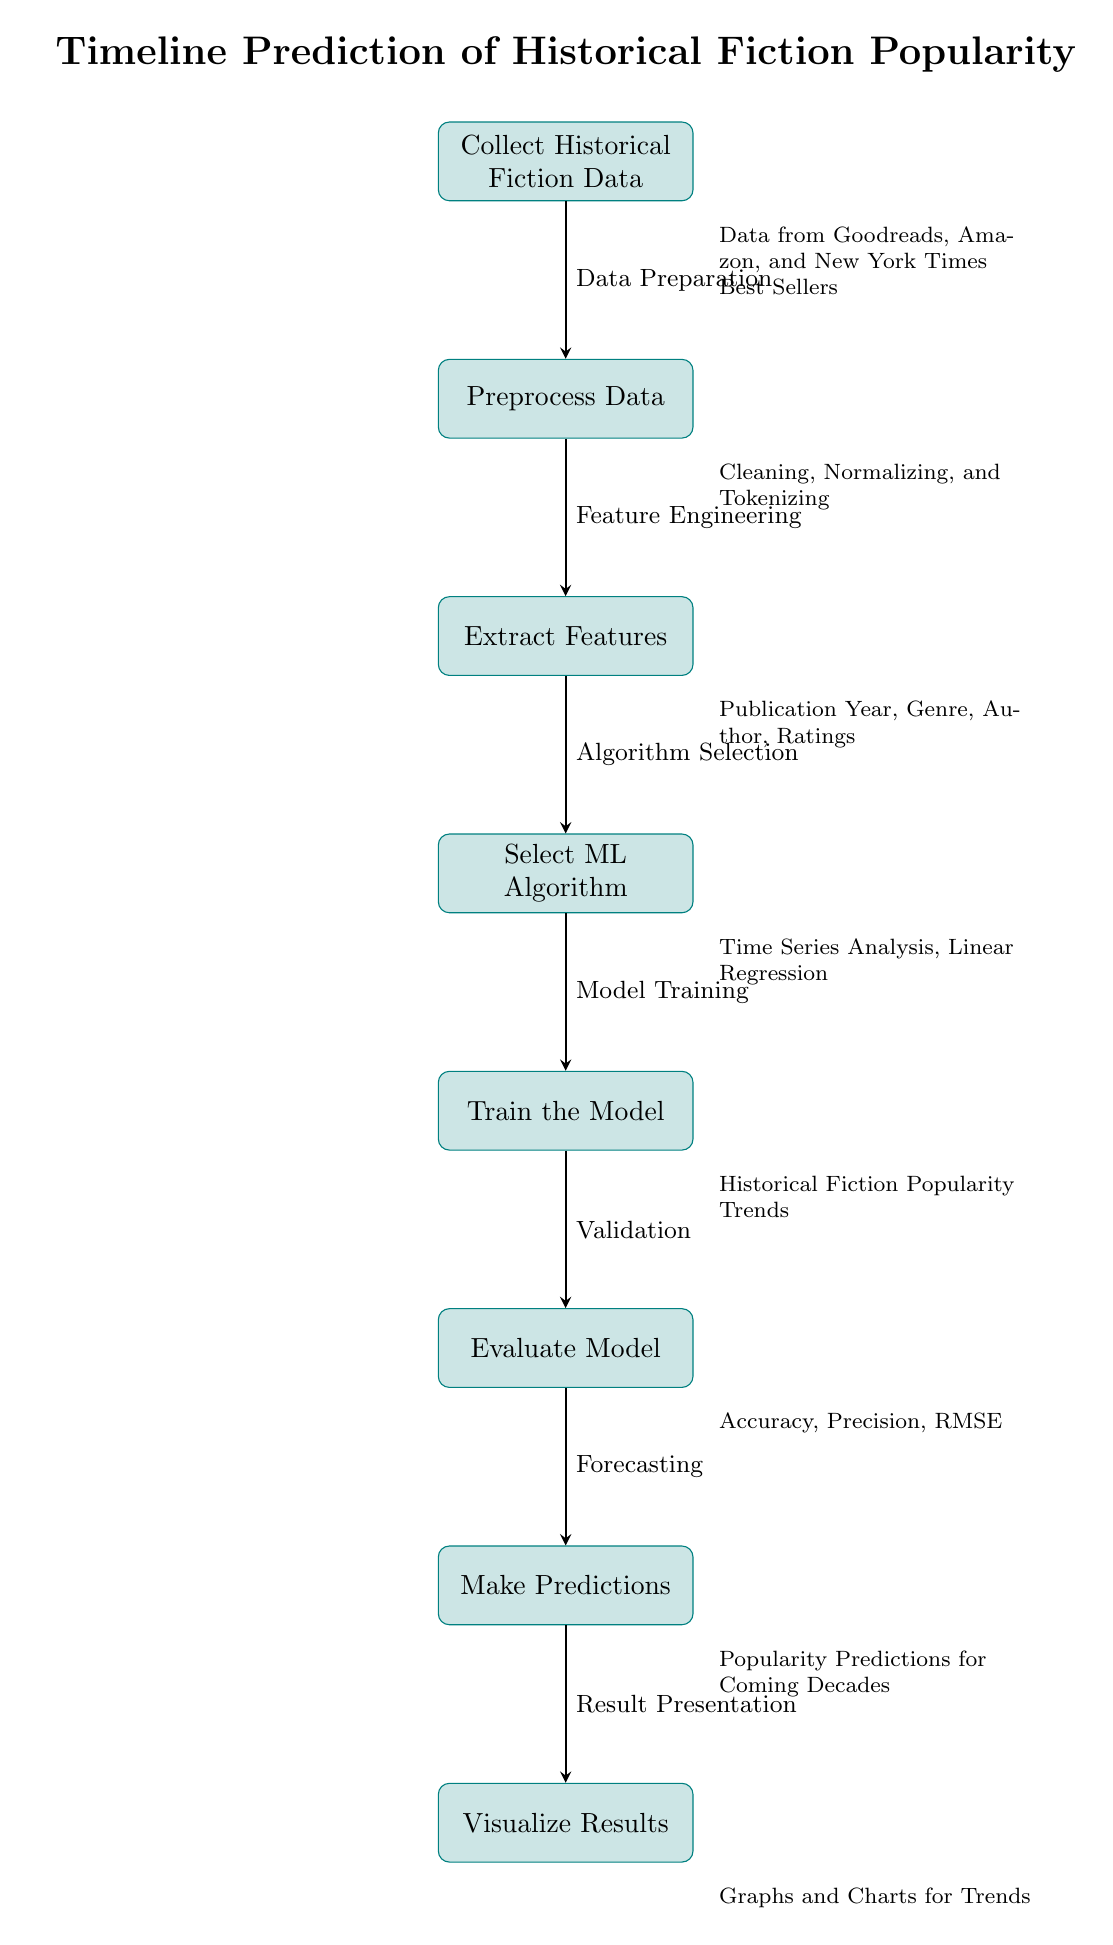What is the first step in the diagram? The first step is "Collect Historical Fiction Data." This is directly stated in the first node of the diagram.
Answer: Collect Historical Fiction Data How many main processes are displayed in the diagram? There are eight main processes illustrated in the diagram, each represented as a node. Counting each node gives a total of eight.
Answer: Eight What does the arrow from "Preprocess Data" to "Extract Features" indicate? The arrow signifies a transition or progression from one step to the next, specifically from data preprocessing to feature extraction, indicating that feature extraction occurs after data preprocessing.
Answer: Feature Engineering Which nodes are connected by the arrow labeled "Validation"? The nodes connected by the "Validation" arrow are "Train the Model" and "Evaluate Model," indicating that model evaluation follows model training.
Answer: Train the Model and Evaluate Model What type of analysis is mentioned in the "Select ML Algorithm" step? The analysis type mentioned is "Time Series Analysis," which is indicated in the description associated with the "Select ML Algorithm" node.
Answer: Time Series Analysis What kind of results are visualized at the end of the process? The results that are visualized at the end of the process include "Graphs and Charts for Trends," as specified in the final node's description.
Answer: Graphs and Charts for Trends What is the purpose of the "Make Predictions" step? The purpose of the "Make Predictions" step is to forecast future popularity trends in historical fiction based on the model outputs from previous steps.
Answer: Popularity Predictions for Coming Decades How does "Evaluate Model" relate to "Train the Model"? The "Evaluate Model" step relates to "Train the Model" as it follows the training process, indicating that evaluation is necessary to determine the model's effectiveness after it has been trained.
Answer: Validation What does the diagram represent overall? The overall representation of the diagram is "Timeline Prediction of Historical Fiction Popularity Over Decades," indicating its focus on forecasting trends in this genre over time.
Answer: Timeline Prediction of Historical Fiction Popularity 